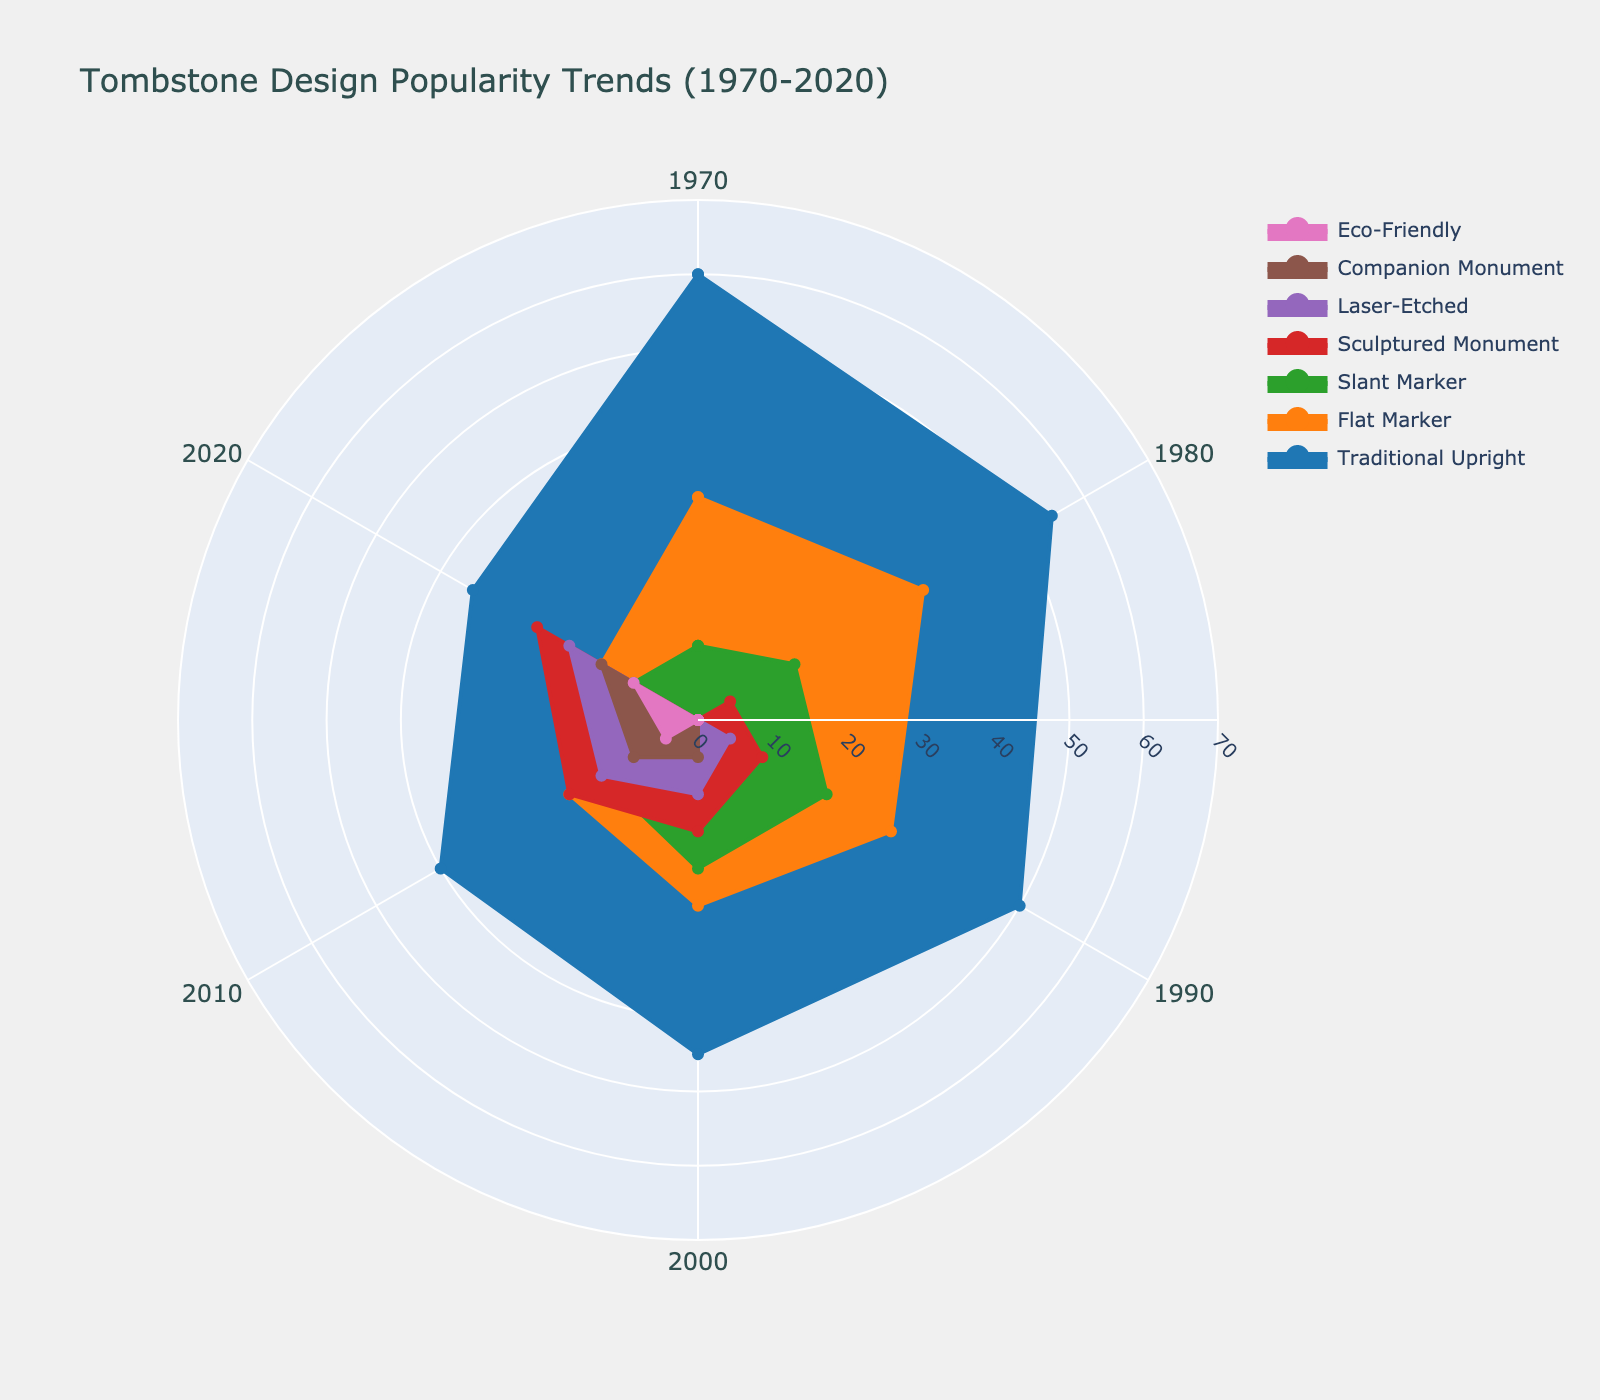What's the title of the figure? The title of the figure is typically placed at or near the top of the chart. In this case, it reads "Tombstone Design Popularity Trends (1970-2020)." This is visibly shown at the top of the figure.
Answer: Tombstone Design Popularity Trends (1970-2020) Which tombstone design had the highest popularity in 1970? Look at the radial axis corresponding to 1970 and identify the highest value among all the designs. The Traditional Upright reaches 60, which is the highest value among the designs for that year.
Answer: Traditional Upright How did the popularity of the Flat Marker design change from 1970 to 2020? Trace the line for Flat Marker design from 1970 to 2020. In 1970, the popularity was 30; it gradually decreases over the years and reaches 15 in 2020.
Answer: Decreased by 15 Which design had the steepest increase in popularity from 2010 to 2020? Compare the slopes of all the designs' lines from 2010 to 2020. Sculptured Monument increases steeply from 20 to 25, Laser-Etched from 15 to 20, Companion Monument from 10 to 15, and Eco-Friendly from 5 to 10. Sculptured Monument has the smallest increase (5 units).
Answer: Sculptured Monument How many designs were consistently present throughout all the years from 1970 to 2020? Examine the lines representing each design in the plot. Traditional Upright, Flat Marker, and Slant Marker are visible throughout all the years from 1970 to 2020.
Answer: 3 What design emerged in the 1990s but showed the lowest popularity in each subsequent decade? Identify the designs that first appear in the 1990s and track their popularity over the years. Laser-Etched appears in 1990 with a gradual increase, but Companion Monument emerges in 2000, and Eco-Friendly in 2010. However, the lowest trend for 5 units belongs to Eco-Friendly.
Answer: Laser-Etched Which tombstone design had the lowest overall popularity in 2020? Analyze the radial axis values for 2020 for each design. The Slant Marker reaches the lowest value of 10 in this year.
Answer: Slant Marker Between 1980 and 2000, what was the trend in popularity for the Traditional Upright design? Follow the line for Traditional Upright from 1980 to 2000. It starts at 55 in 1980, decreases to 50 in 1990, and goes down further to 45 in 2000. This is a steadily decreasing trend.
Answer: Steadily decreasing What is the average popularity of the Sculptured Monument design over the years it appears on the chart? Identify the popularity values for Sculptured Monument in each year: 5 (1980), 10 (1990), 15 (2000), 20 (2010), 25 (2020). The average is calculated as (5 + 10 + 15 + 20 + 25) / 5 = 15.
Answer: 15 Which design had the biggest change in popularity from one decade to the next? Evaluate the popularity changes from one decade to the next for each design. Compare increments and decrements for each decade. Traditional Upright’s biggest drop from 1970 to 1980 (60 to 55), reducing by 5 units consistently over time.
Answer: Traditional Upright 